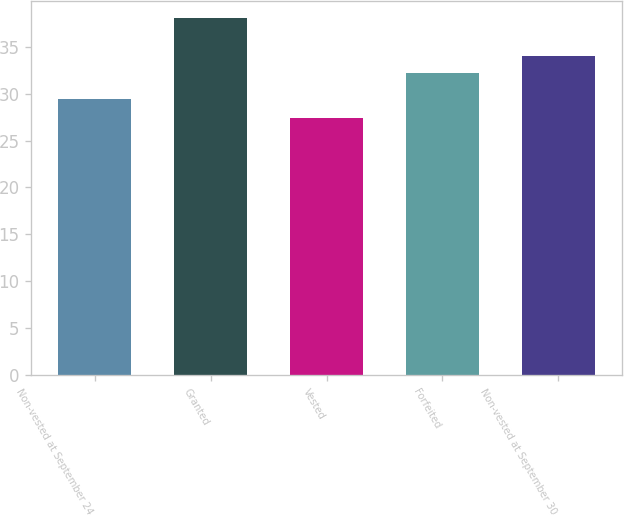Convert chart to OTSL. <chart><loc_0><loc_0><loc_500><loc_500><bar_chart><fcel>Non-vested at September 24<fcel>Granted<fcel>Vested<fcel>Forfeited<fcel>Non-vested at September 30<nl><fcel>29.4<fcel>38.03<fcel>27.43<fcel>32.21<fcel>34.06<nl></chart> 